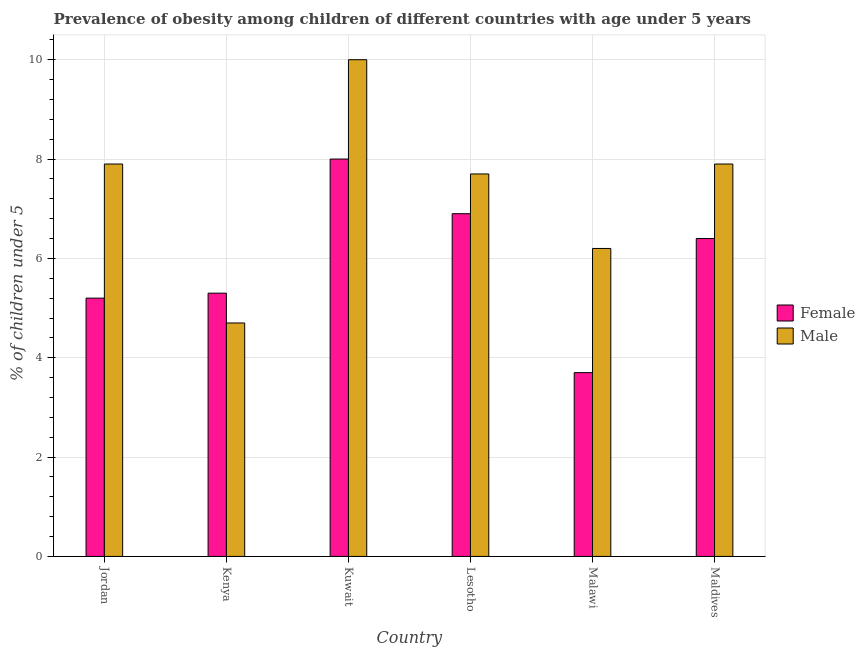Are the number of bars per tick equal to the number of legend labels?
Your response must be concise. Yes. Are the number of bars on each tick of the X-axis equal?
Make the answer very short. Yes. How many bars are there on the 6th tick from the right?
Offer a very short reply. 2. What is the label of the 6th group of bars from the left?
Keep it short and to the point. Maldives. What is the percentage of obese male children in Maldives?
Ensure brevity in your answer.  7.9. Across all countries, what is the maximum percentage of obese male children?
Keep it short and to the point. 10. Across all countries, what is the minimum percentage of obese female children?
Your answer should be compact. 3.7. In which country was the percentage of obese male children maximum?
Give a very brief answer. Kuwait. In which country was the percentage of obese female children minimum?
Keep it short and to the point. Malawi. What is the total percentage of obese female children in the graph?
Your response must be concise. 35.5. What is the difference between the percentage of obese female children in Jordan and that in Kuwait?
Make the answer very short. -2.8. What is the difference between the percentage of obese male children in Malawi and the percentage of obese female children in Kuwait?
Offer a terse response. -1.8. What is the average percentage of obese female children per country?
Your answer should be very brief. 5.92. What is the difference between the percentage of obese male children and percentage of obese female children in Lesotho?
Your answer should be compact. 0.8. In how many countries, is the percentage of obese female children greater than 3.2 %?
Ensure brevity in your answer.  6. What is the ratio of the percentage of obese female children in Kenya to that in Maldives?
Provide a short and direct response. 0.83. Is the difference between the percentage of obese female children in Jordan and Kenya greater than the difference between the percentage of obese male children in Jordan and Kenya?
Your answer should be very brief. No. What is the difference between the highest and the second highest percentage of obese female children?
Make the answer very short. 1.1. What is the difference between the highest and the lowest percentage of obese female children?
Offer a very short reply. 4.3. What does the 1st bar from the left in Lesotho represents?
Your answer should be compact. Female. What does the 2nd bar from the right in Kenya represents?
Make the answer very short. Female. What is the difference between two consecutive major ticks on the Y-axis?
Your answer should be compact. 2. Are the values on the major ticks of Y-axis written in scientific E-notation?
Provide a short and direct response. No. Does the graph contain any zero values?
Your answer should be very brief. No. Does the graph contain grids?
Your answer should be very brief. Yes. Where does the legend appear in the graph?
Give a very brief answer. Center right. How are the legend labels stacked?
Make the answer very short. Vertical. What is the title of the graph?
Your answer should be very brief. Prevalence of obesity among children of different countries with age under 5 years. What is the label or title of the Y-axis?
Provide a succinct answer.  % of children under 5. What is the  % of children under 5 in Female in Jordan?
Your answer should be compact. 5.2. What is the  % of children under 5 in Male in Jordan?
Provide a succinct answer. 7.9. What is the  % of children under 5 of Female in Kenya?
Provide a succinct answer. 5.3. What is the  % of children under 5 of Male in Kenya?
Offer a terse response. 4.7. What is the  % of children under 5 in Female in Kuwait?
Your answer should be compact. 8. What is the  % of children under 5 of Male in Kuwait?
Keep it short and to the point. 10. What is the  % of children under 5 in Female in Lesotho?
Your response must be concise. 6.9. What is the  % of children under 5 of Male in Lesotho?
Give a very brief answer. 7.7. What is the  % of children under 5 of Female in Malawi?
Your response must be concise. 3.7. What is the  % of children under 5 in Male in Malawi?
Provide a short and direct response. 6.2. What is the  % of children under 5 of Female in Maldives?
Your response must be concise. 6.4. What is the  % of children under 5 of Male in Maldives?
Your answer should be compact. 7.9. Across all countries, what is the maximum  % of children under 5 in Male?
Your answer should be compact. 10. Across all countries, what is the minimum  % of children under 5 in Female?
Provide a succinct answer. 3.7. Across all countries, what is the minimum  % of children under 5 in Male?
Your response must be concise. 4.7. What is the total  % of children under 5 of Female in the graph?
Offer a terse response. 35.5. What is the total  % of children under 5 in Male in the graph?
Offer a terse response. 44.4. What is the difference between the  % of children under 5 in Female in Jordan and that in Kenya?
Your answer should be very brief. -0.1. What is the difference between the  % of children under 5 in Male in Jordan and that in Kenya?
Your answer should be very brief. 3.2. What is the difference between the  % of children under 5 of Male in Jordan and that in Kuwait?
Offer a terse response. -2.1. What is the difference between the  % of children under 5 of Female in Jordan and that in Lesotho?
Your response must be concise. -1.7. What is the difference between the  % of children under 5 in Male in Jordan and that in Lesotho?
Offer a very short reply. 0.2. What is the difference between the  % of children under 5 in Female in Jordan and that in Malawi?
Keep it short and to the point. 1.5. What is the difference between the  % of children under 5 in Male in Jordan and that in Malawi?
Give a very brief answer. 1.7. What is the difference between the  % of children under 5 in Male in Jordan and that in Maldives?
Make the answer very short. 0. What is the difference between the  % of children under 5 of Male in Kenya and that in Kuwait?
Offer a very short reply. -5.3. What is the difference between the  % of children under 5 in Male in Kenya and that in Lesotho?
Offer a terse response. -3. What is the difference between the  % of children under 5 of Female in Kenya and that in Malawi?
Provide a succinct answer. 1.6. What is the difference between the  % of children under 5 in Male in Kenya and that in Malawi?
Offer a terse response. -1.5. What is the difference between the  % of children under 5 of Female in Kenya and that in Maldives?
Ensure brevity in your answer.  -1.1. What is the difference between the  % of children under 5 of Male in Kenya and that in Maldives?
Make the answer very short. -3.2. What is the difference between the  % of children under 5 in Female in Kuwait and that in Lesotho?
Offer a very short reply. 1.1. What is the difference between the  % of children under 5 in Female in Kuwait and that in Malawi?
Provide a short and direct response. 4.3. What is the difference between the  % of children under 5 in Male in Kuwait and that in Malawi?
Provide a succinct answer. 3.8. What is the difference between the  % of children under 5 of Female in Lesotho and that in Malawi?
Ensure brevity in your answer.  3.2. What is the difference between the  % of children under 5 in Male in Lesotho and that in Malawi?
Your answer should be very brief. 1.5. What is the difference between the  % of children under 5 of Female in Lesotho and that in Maldives?
Ensure brevity in your answer.  0.5. What is the difference between the  % of children under 5 in Female in Jordan and the  % of children under 5 in Male in Kenya?
Your response must be concise. 0.5. What is the difference between the  % of children under 5 in Female in Jordan and the  % of children under 5 in Male in Kuwait?
Make the answer very short. -4.8. What is the difference between the  % of children under 5 of Female in Jordan and the  % of children under 5 of Male in Malawi?
Your answer should be very brief. -1. What is the difference between the  % of children under 5 of Female in Jordan and the  % of children under 5 of Male in Maldives?
Your answer should be compact. -2.7. What is the difference between the  % of children under 5 in Female in Kenya and the  % of children under 5 in Male in Maldives?
Provide a short and direct response. -2.6. What is the difference between the  % of children under 5 of Female in Kuwait and the  % of children under 5 of Male in Lesotho?
Your answer should be compact. 0.3. What is the difference between the  % of children under 5 in Female in Kuwait and the  % of children under 5 in Male in Malawi?
Your response must be concise. 1.8. What is the difference between the  % of children under 5 in Female in Kuwait and the  % of children under 5 in Male in Maldives?
Provide a short and direct response. 0.1. What is the difference between the  % of children under 5 of Female in Malawi and the  % of children under 5 of Male in Maldives?
Ensure brevity in your answer.  -4.2. What is the average  % of children under 5 in Female per country?
Ensure brevity in your answer.  5.92. What is the average  % of children under 5 in Male per country?
Provide a succinct answer. 7.4. What is the difference between the  % of children under 5 of Female and  % of children under 5 of Male in Jordan?
Keep it short and to the point. -2.7. What is the difference between the  % of children under 5 of Female and  % of children under 5 of Male in Kenya?
Your answer should be compact. 0.6. What is the difference between the  % of children under 5 of Female and  % of children under 5 of Male in Maldives?
Give a very brief answer. -1.5. What is the ratio of the  % of children under 5 in Female in Jordan to that in Kenya?
Your answer should be compact. 0.98. What is the ratio of the  % of children under 5 in Male in Jordan to that in Kenya?
Make the answer very short. 1.68. What is the ratio of the  % of children under 5 of Female in Jordan to that in Kuwait?
Your answer should be very brief. 0.65. What is the ratio of the  % of children under 5 of Male in Jordan to that in Kuwait?
Your answer should be very brief. 0.79. What is the ratio of the  % of children under 5 of Female in Jordan to that in Lesotho?
Keep it short and to the point. 0.75. What is the ratio of the  % of children under 5 in Male in Jordan to that in Lesotho?
Your answer should be very brief. 1.03. What is the ratio of the  % of children under 5 in Female in Jordan to that in Malawi?
Your answer should be very brief. 1.41. What is the ratio of the  % of children under 5 in Male in Jordan to that in Malawi?
Your answer should be compact. 1.27. What is the ratio of the  % of children under 5 in Female in Jordan to that in Maldives?
Offer a terse response. 0.81. What is the ratio of the  % of children under 5 of Female in Kenya to that in Kuwait?
Offer a very short reply. 0.66. What is the ratio of the  % of children under 5 in Male in Kenya to that in Kuwait?
Give a very brief answer. 0.47. What is the ratio of the  % of children under 5 of Female in Kenya to that in Lesotho?
Ensure brevity in your answer.  0.77. What is the ratio of the  % of children under 5 in Male in Kenya to that in Lesotho?
Keep it short and to the point. 0.61. What is the ratio of the  % of children under 5 of Female in Kenya to that in Malawi?
Provide a succinct answer. 1.43. What is the ratio of the  % of children under 5 of Male in Kenya to that in Malawi?
Ensure brevity in your answer.  0.76. What is the ratio of the  % of children under 5 of Female in Kenya to that in Maldives?
Provide a succinct answer. 0.83. What is the ratio of the  % of children under 5 in Male in Kenya to that in Maldives?
Your response must be concise. 0.59. What is the ratio of the  % of children under 5 of Female in Kuwait to that in Lesotho?
Ensure brevity in your answer.  1.16. What is the ratio of the  % of children under 5 in Male in Kuwait to that in Lesotho?
Provide a short and direct response. 1.3. What is the ratio of the  % of children under 5 of Female in Kuwait to that in Malawi?
Your answer should be very brief. 2.16. What is the ratio of the  % of children under 5 in Male in Kuwait to that in Malawi?
Your response must be concise. 1.61. What is the ratio of the  % of children under 5 in Male in Kuwait to that in Maldives?
Give a very brief answer. 1.27. What is the ratio of the  % of children under 5 of Female in Lesotho to that in Malawi?
Provide a short and direct response. 1.86. What is the ratio of the  % of children under 5 in Male in Lesotho to that in Malawi?
Your answer should be very brief. 1.24. What is the ratio of the  % of children under 5 of Female in Lesotho to that in Maldives?
Make the answer very short. 1.08. What is the ratio of the  % of children under 5 in Male in Lesotho to that in Maldives?
Provide a short and direct response. 0.97. What is the ratio of the  % of children under 5 in Female in Malawi to that in Maldives?
Give a very brief answer. 0.58. What is the ratio of the  % of children under 5 in Male in Malawi to that in Maldives?
Offer a terse response. 0.78. What is the difference between the highest and the lowest  % of children under 5 of Female?
Make the answer very short. 4.3. 